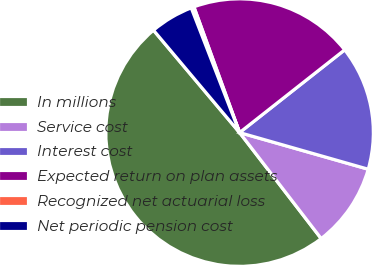<chart> <loc_0><loc_0><loc_500><loc_500><pie_chart><fcel>In millions<fcel>Service cost<fcel>Interest cost<fcel>Expected return on plan assets<fcel>Recognized net actuarial loss<fcel>Net periodic pension cost<nl><fcel>49.31%<fcel>10.14%<fcel>15.03%<fcel>19.93%<fcel>0.34%<fcel>5.24%<nl></chart> 